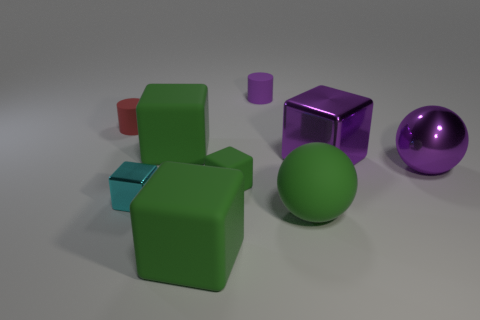What number of cyan metallic objects are there?
Your answer should be compact. 1. Is there anything else that is made of the same material as the tiny green block?
Keep it short and to the point. Yes. There is another tiny object that is the same shape as the purple matte thing; what material is it?
Offer a terse response. Rubber. Are there fewer large green rubber balls that are to the left of the big purple sphere than metal spheres?
Provide a short and direct response. No. There is a large green matte thing that is behind the large rubber sphere; is its shape the same as the small green object?
Provide a succinct answer. Yes. Is there anything else of the same color as the metal sphere?
Your response must be concise. Yes. There is a green sphere that is made of the same material as the red object; what size is it?
Your answer should be compact. Large. What is the material of the big green block right of the big block to the left of the big green object that is in front of the large rubber sphere?
Give a very brief answer. Rubber. Are there fewer big green balls than tiny green metal cylinders?
Ensure brevity in your answer.  No. Are the red cylinder and the tiny green thing made of the same material?
Your answer should be very brief. Yes. 